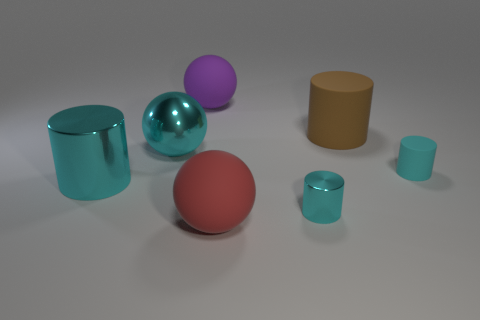Subtract all blue balls. How many cyan cylinders are left? 3 Subtract 1 cylinders. How many cylinders are left? 3 Add 2 large cyan cylinders. How many objects exist? 9 Subtract all balls. How many objects are left? 4 Subtract all blocks. Subtract all big cyan shiny spheres. How many objects are left? 6 Add 1 big red objects. How many big red objects are left? 2 Add 3 red matte objects. How many red matte objects exist? 4 Subtract 0 green balls. How many objects are left? 7 